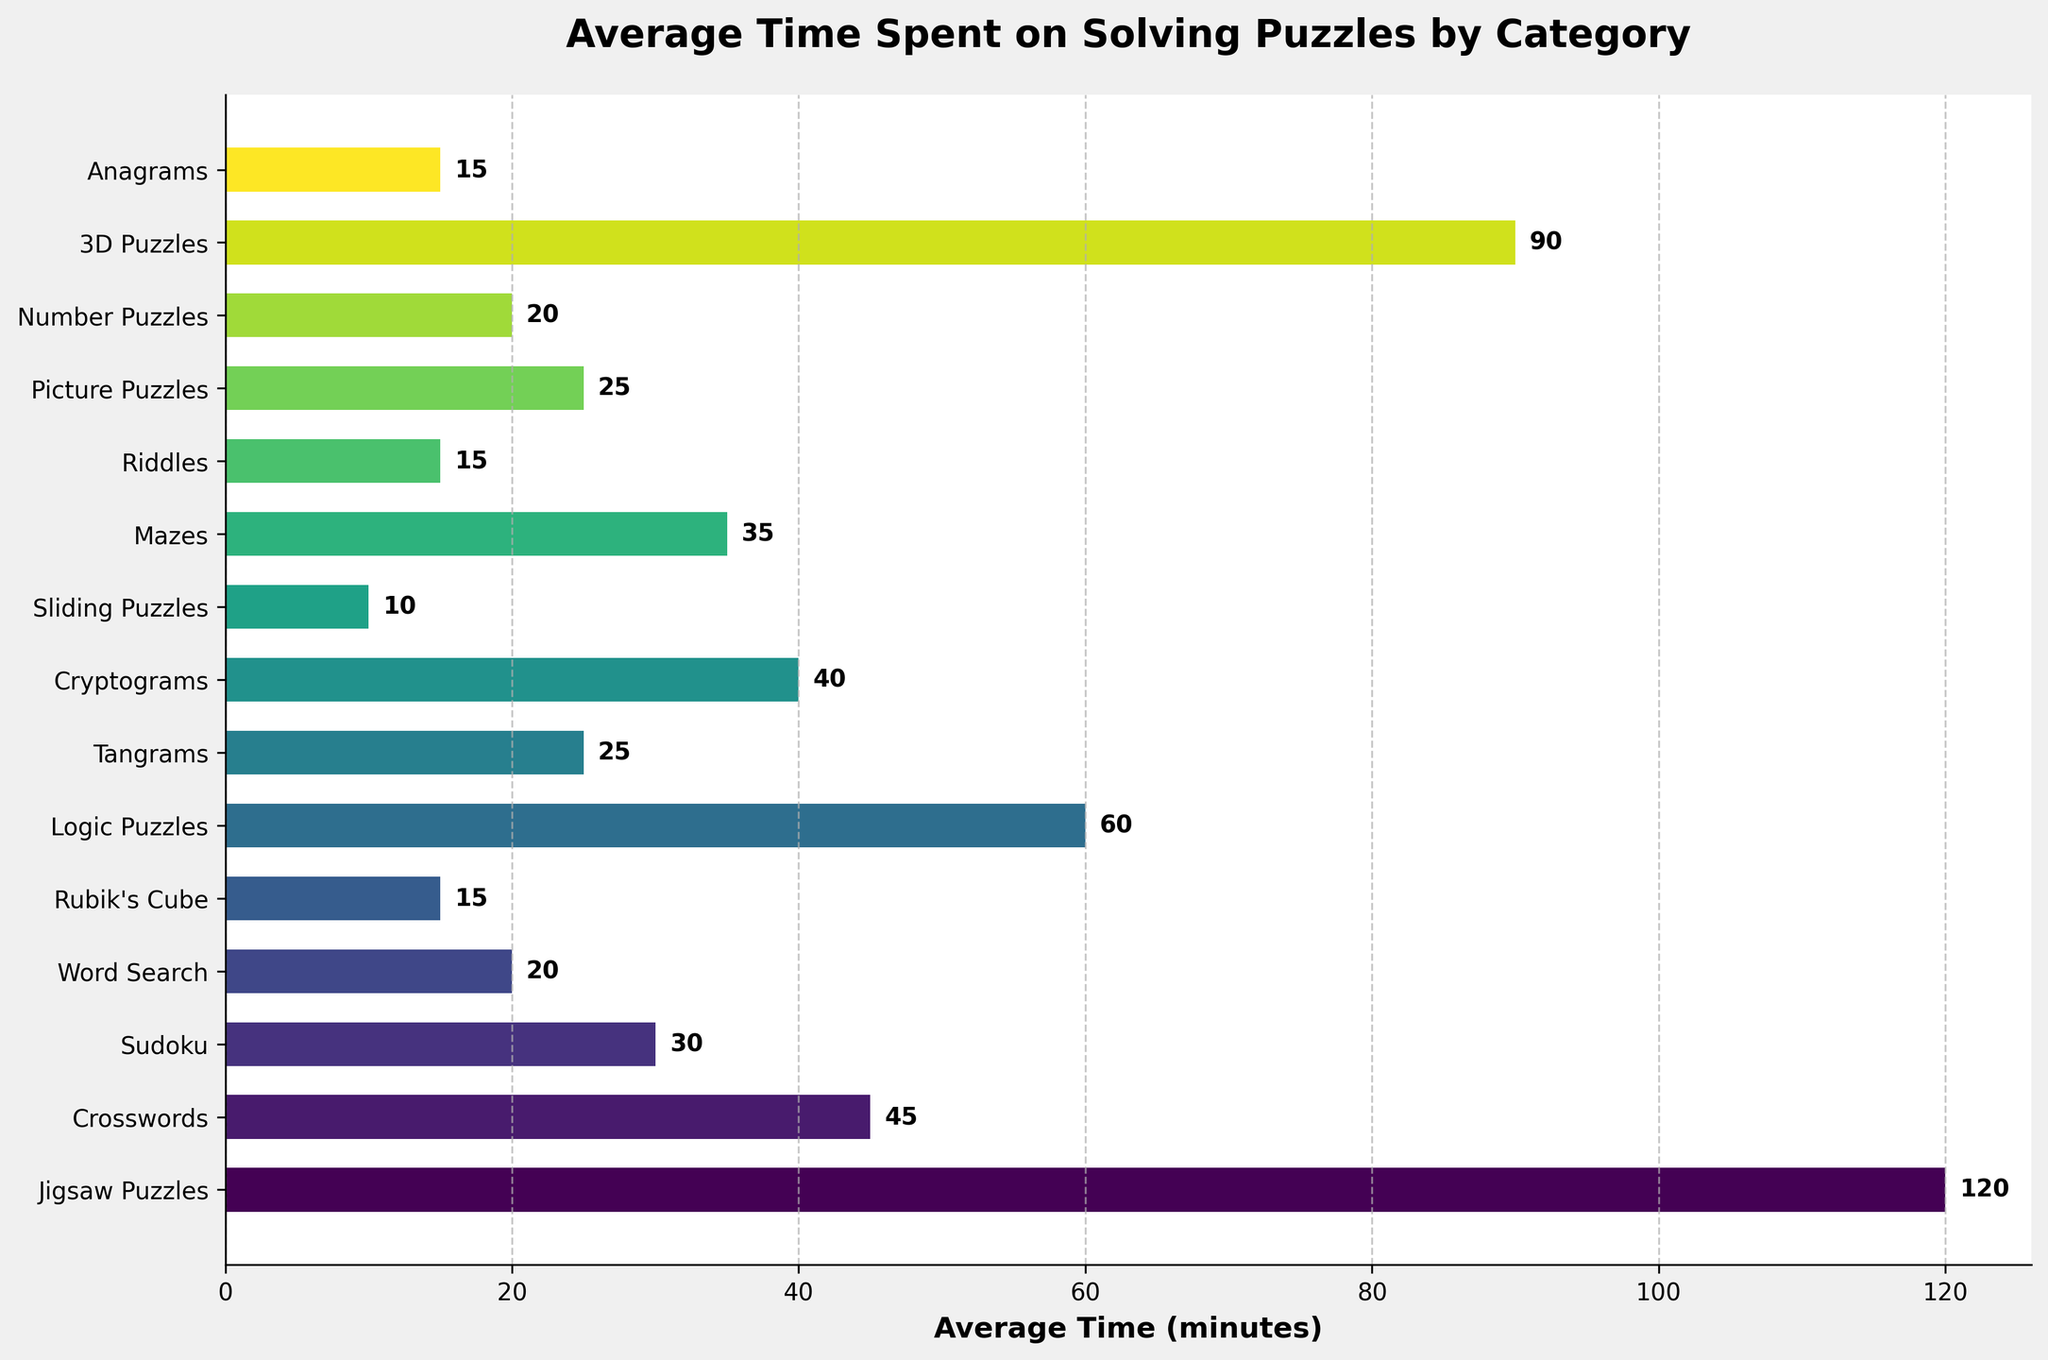Which puzzle category takes the longest average time to solve? The category with the highest bar corresponds to the longest average time, which is Jigsaw Puzzles with an average of 120 minutes.
Answer: Jigsaw Puzzles Which puzzle category takes the shortest average time to solve? The category with the shortest bar has the shortest average time, which is Sliding Puzzles with an average of 10 minutes.
Answer: Sliding Puzzles How much longer on average does it take to solve a Jigsaw Puzzle compared to a Crossword? Subtract the average time for Crosswords from that for Jigsaw Puzzles: 120 - 45 = 75.
Answer: 75 minutes Which categories take an average time of 20 minutes to solve? Look for categories with bars ending at 20 on the x-axis: Word Search and Number Puzzles.
Answer: Word Search, Number Puzzles What is the total average time spent on solving Rubik's Cube, Tangrams, and Anagrams combined? Sum the average times for Rubik's Cube, Tangrams, and Anagrams: 15 + 25 + 15 = 55.
Answer: 55 minutes Is it true that Logic Puzzles take less average time to solve than 3D Puzzles? Compare the average times of Logic Puzzles (60 minutes) and 3D Puzzles (90 minutes). Logic Puzzles take less time.
Answer: Yes Among Word Search, Riddles, and Picture Puzzles, which has the highest average solving time? Compare the average times: Word Search (20 minutes), Riddles (15 minutes), Picture Puzzles (25 minutes). Picture Puzzles has the highest average time.
Answer: Picture Puzzles How does the average time spent on solving Sudoku compare to that of Mazes? Compare the average times: Sudoku (30 minutes) and Mazes (35 minutes). Mazes take more time.
Answer: Mazes take more time If you add the average solving time for Crosswords and Cryptograms, how does the total compare to the average time for 3D Puzzles? Sum the average time of Crosswords (45 minutes) and Cryptograms (40 minutes): 45 + 40 = 85 minutes. Compare with 3D Puzzles (90 minutes). The total is less.
Answer: Less What is the difference in average solving time between the longest and shortest categories? Subtract the average time of the shortest category (Sliding Puzzles, 10 minutes) from the longest category (Jigsaw Puzzles, 120 minutes): 120 - 10 = 110.
Answer: 110 minutes 